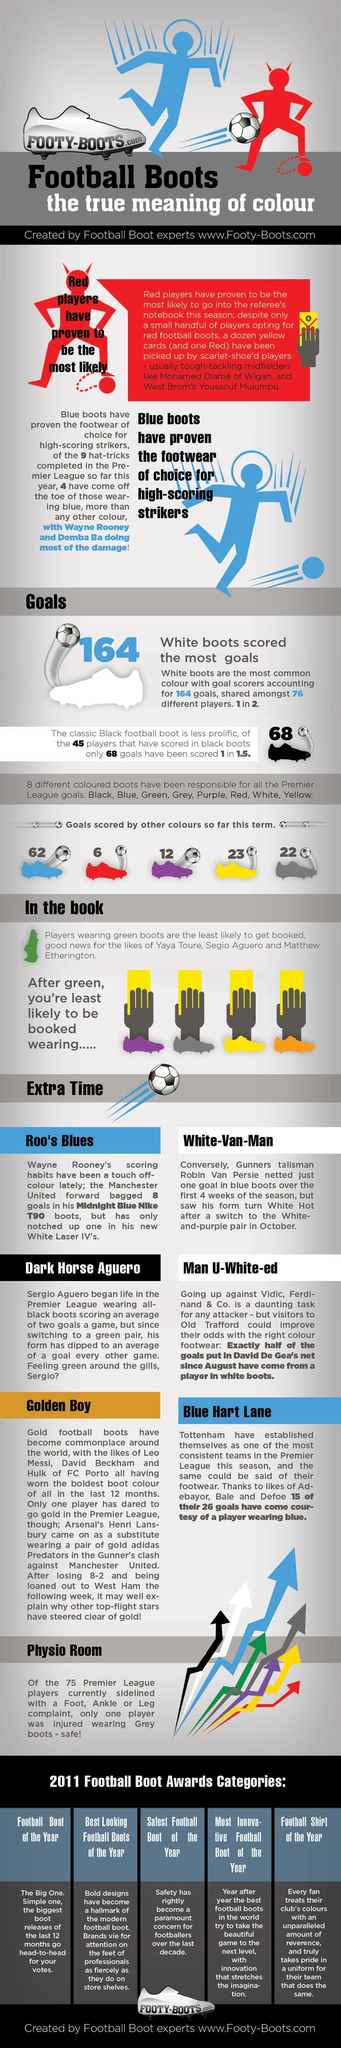How many goals have been scored in premier league by players sporting yellow boots?
Answer the question with a short phrase. 23 Which color of football boots was the least likely to get a yellow card, yellow, orange, or green? green Which is most preferred shoe color by most strikers, red, yellow, or blue? blue 